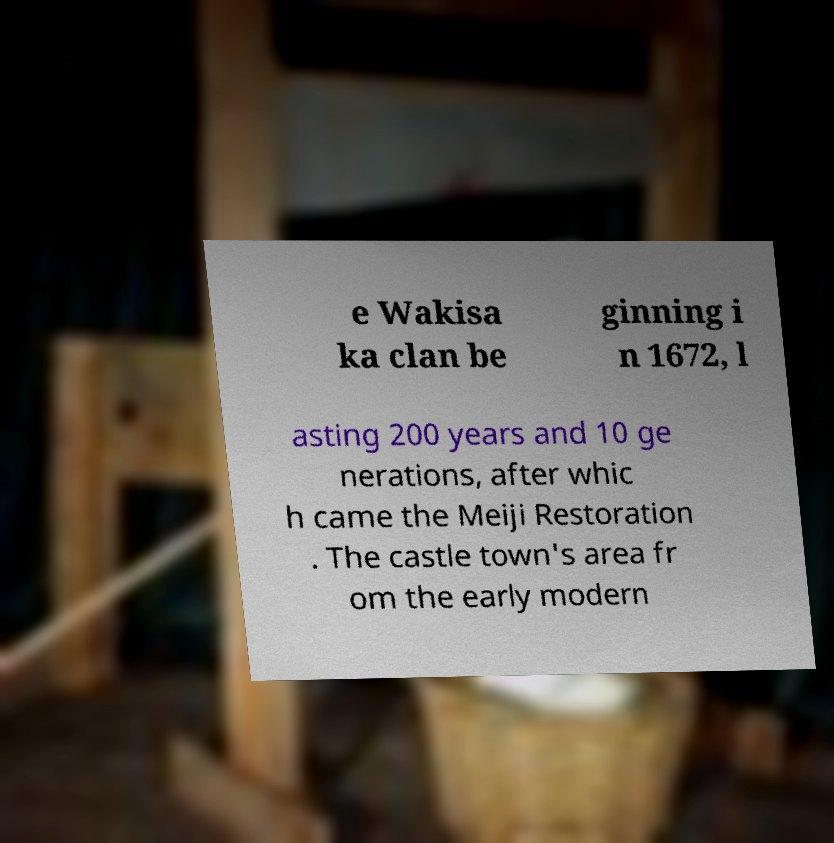There's text embedded in this image that I need extracted. Can you transcribe it verbatim? e Wakisa ka clan be ginning i n 1672, l asting 200 years and 10 ge nerations, after whic h came the Meiji Restoration . The castle town's area fr om the early modern 